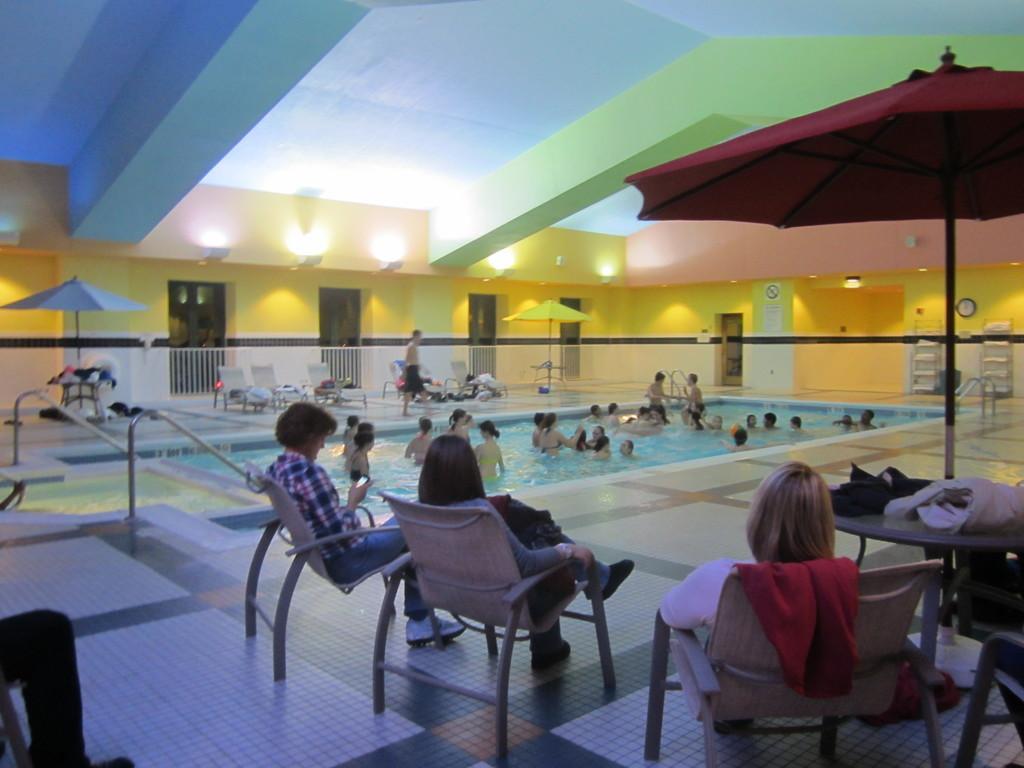Can you describe this image briefly? There are so many people on pool and few people sitting in chairs under a umbrella and a man walking beside the pool. 